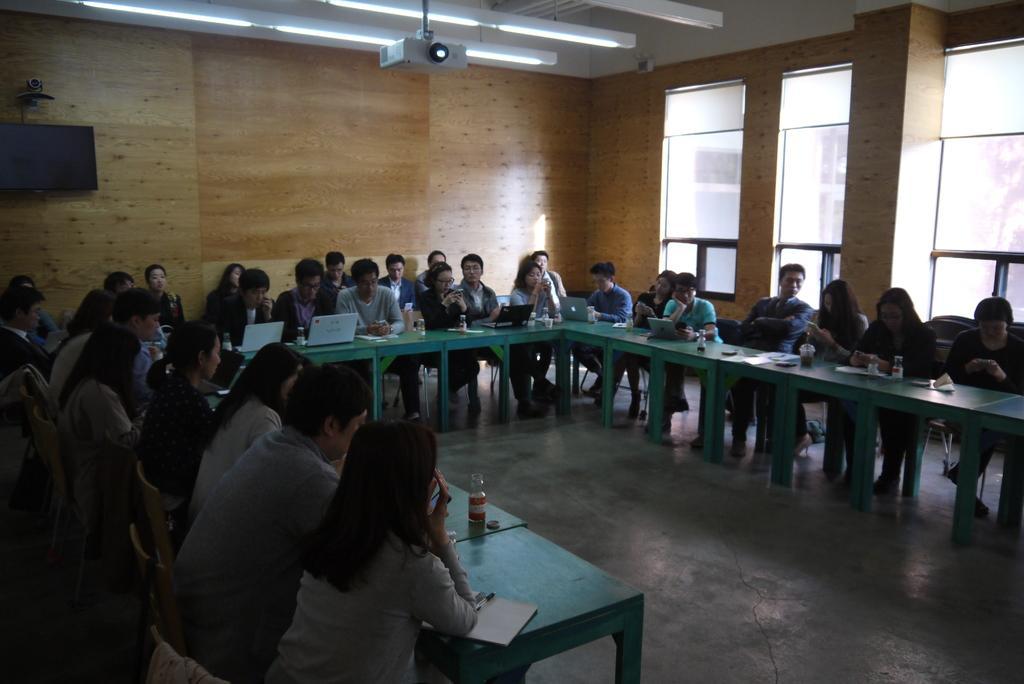Describe this image in one or two sentences. In the image we can see there are many people sitting, they are wearing clothes and some of them are holding objects in their hands. Here we can see tables, on the table, we can see electronic devices, bottles and other things. Here we can see the floor, windows, wall, projector and the lights. 